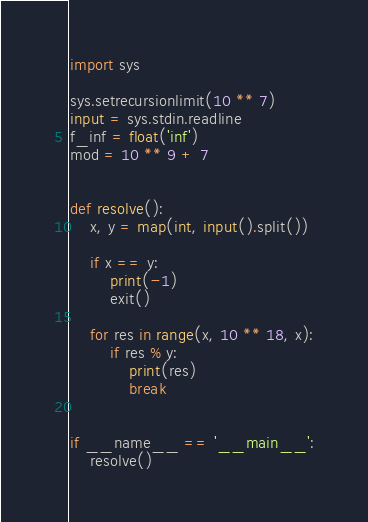<code> <loc_0><loc_0><loc_500><loc_500><_Python_>import sys

sys.setrecursionlimit(10 ** 7)
input = sys.stdin.readline
f_inf = float('inf')
mod = 10 ** 9 + 7


def resolve():
    x, y = map(int, input().split())

    if x == y:
        print(-1)
        exit()

    for res in range(x, 10 ** 18, x):
        if res % y:
            print(res)
            break


if __name__ == '__main__':
    resolve()
</code> 